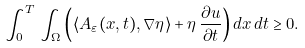<formula> <loc_0><loc_0><loc_500><loc_500>\int _ { 0 } ^ { T } \, \int _ { \Omega } \left ( \langle A _ { \varepsilon } ( x , t ) , \nabla \eta \rangle + \eta \, \frac { \partial u } { \partial t } \right ) d x \, d t \geq 0 .</formula> 